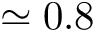Convert formula to latex. <formula><loc_0><loc_0><loc_500><loc_500>\simeq 0 . 8</formula> 